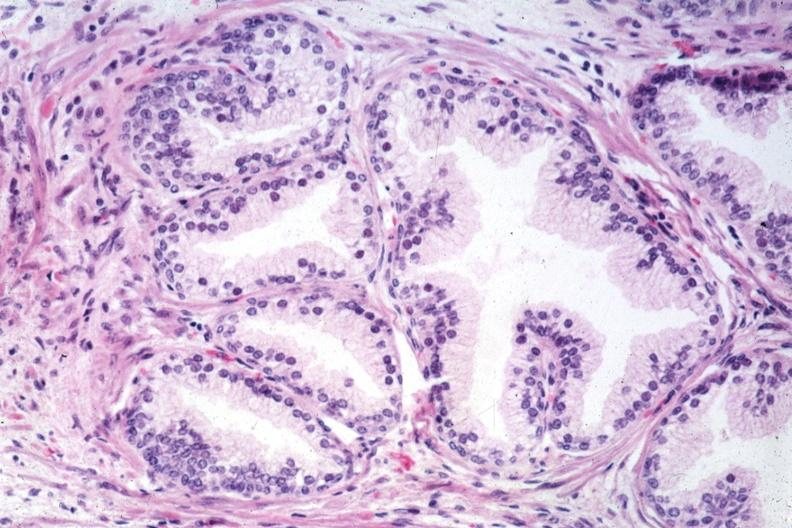what does this image show?
Answer the question using a single word or phrase. Very good example of normal prostate gland 